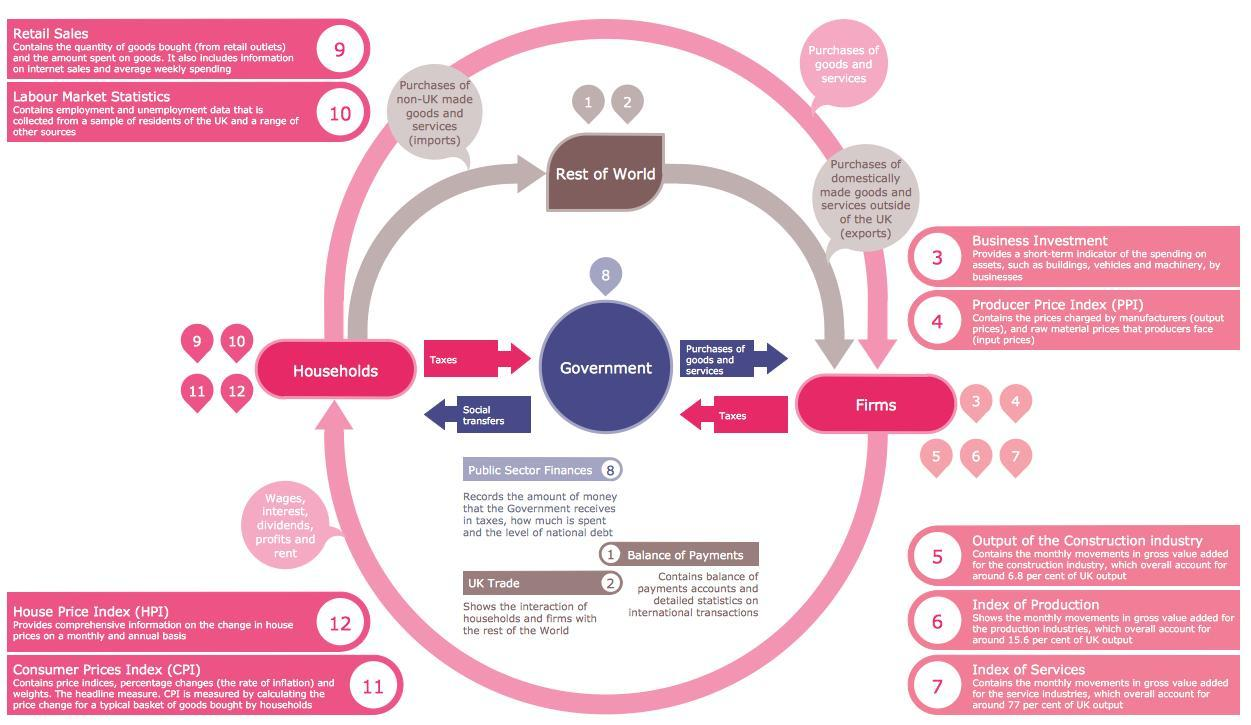Social transfers go where?
Answer the question with a short phrase. Households The light pink arrow is showing the connect between which 2 factors Households, Firms Where do taxes go to Government 